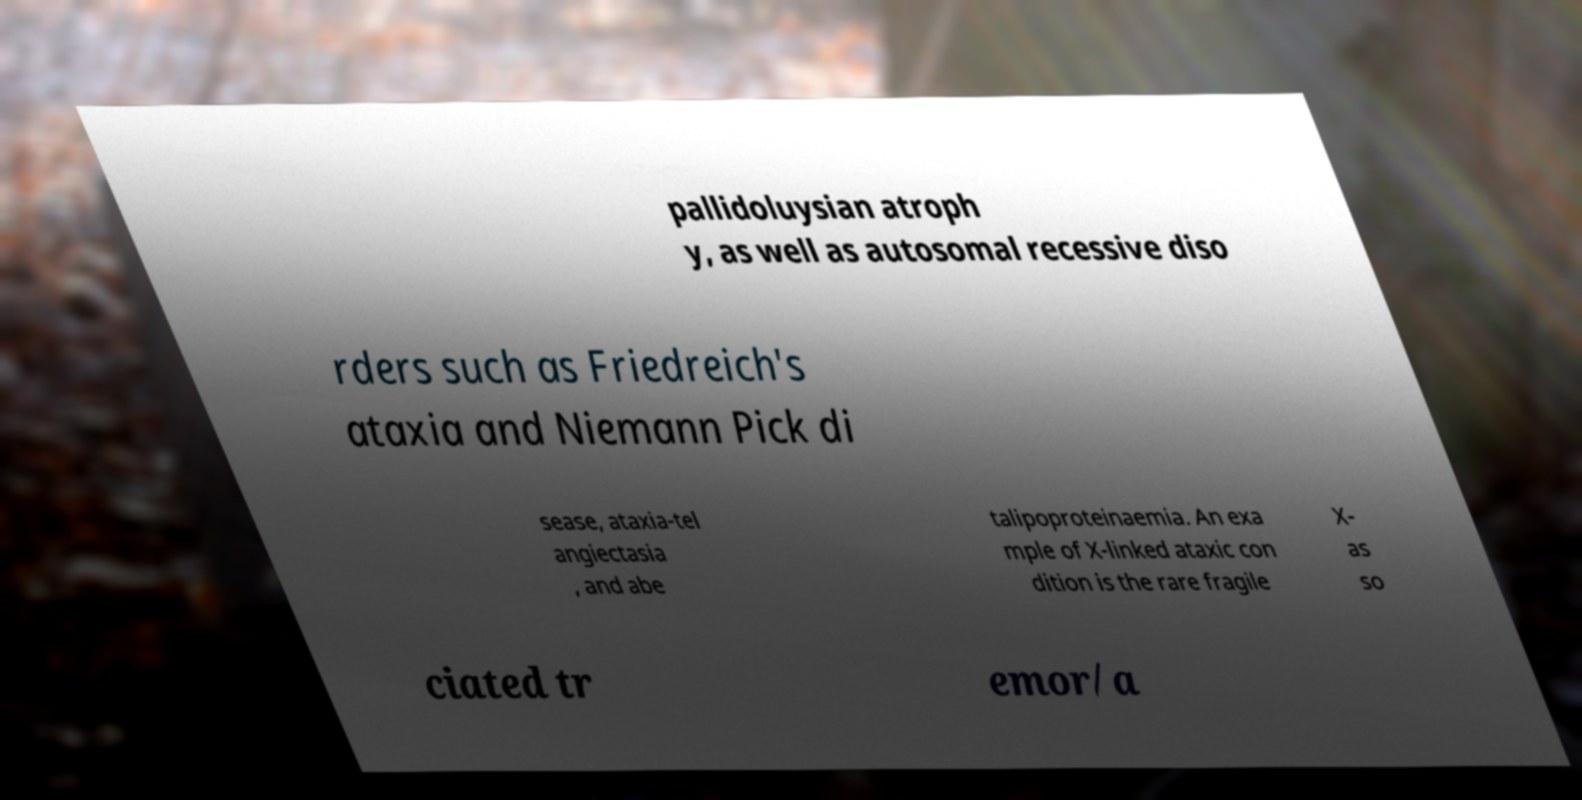Can you read and provide the text displayed in the image?This photo seems to have some interesting text. Can you extract and type it out for me? pallidoluysian atroph y, as well as autosomal recessive diso rders such as Friedreich's ataxia and Niemann Pick di sease, ataxia-tel angiectasia , and abe talipoproteinaemia. An exa mple of X-linked ataxic con dition is the rare fragile X- as so ciated tr emor/a 